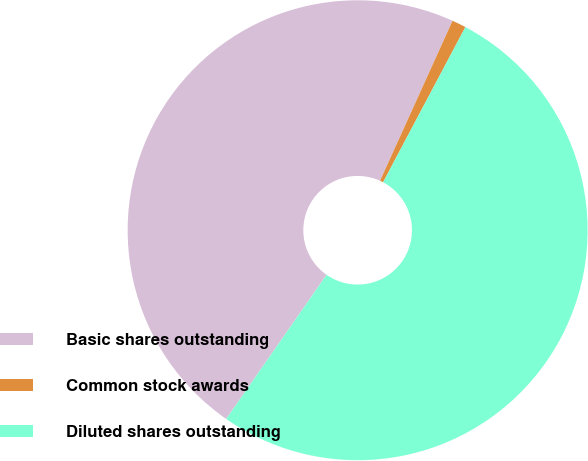<chart> <loc_0><loc_0><loc_500><loc_500><pie_chart><fcel>Basic shares outstanding<fcel>Common stock awards<fcel>Diluted shares outstanding<nl><fcel>47.09%<fcel>0.99%<fcel>51.92%<nl></chart> 